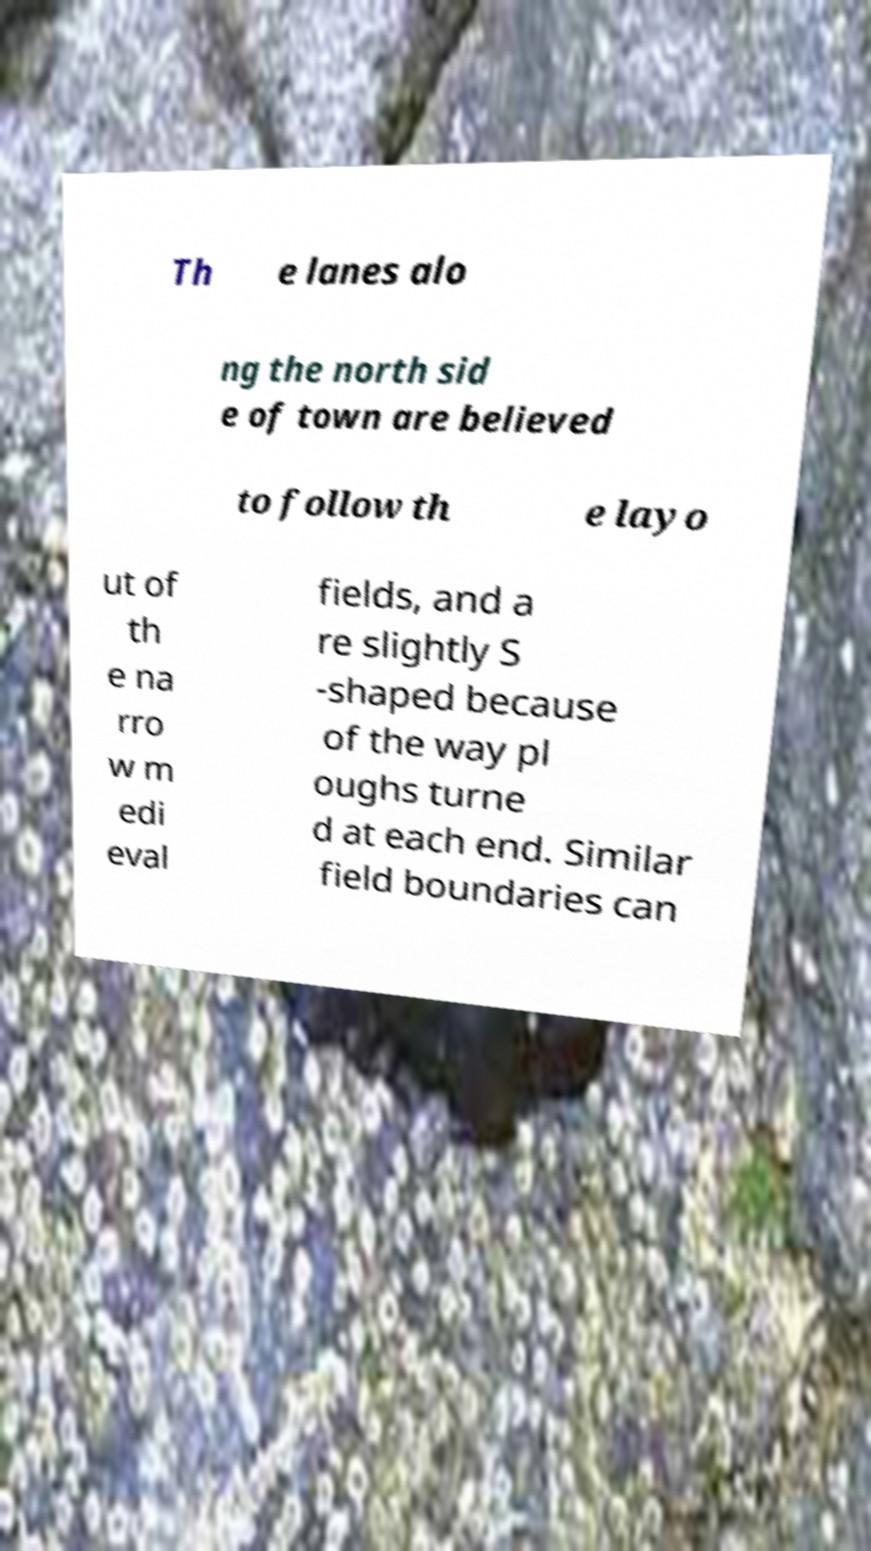Can you accurately transcribe the text from the provided image for me? Th e lanes alo ng the north sid e of town are believed to follow th e layo ut of th e na rro w m edi eval fields, and a re slightly S -shaped because of the way pl oughs turne d at each end. Similar field boundaries can 